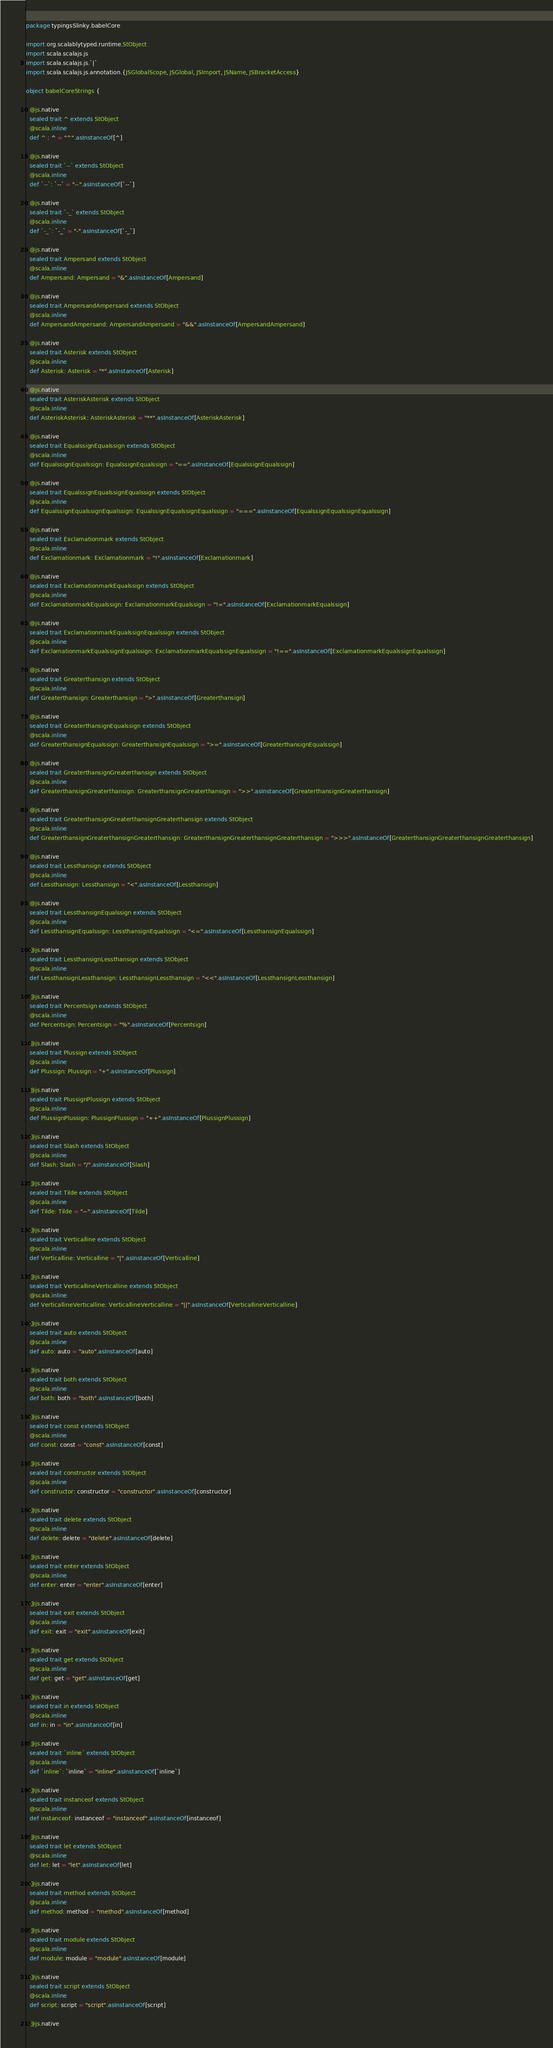<code> <loc_0><loc_0><loc_500><loc_500><_Scala_>package typingsSlinky.babelCore

import org.scalablytyped.runtime.StObject
import scala.scalajs.js
import scala.scalajs.js.`|`
import scala.scalajs.js.annotation.{JSGlobalScope, JSGlobal, JSImport, JSName, JSBracketAccess}

object babelCoreStrings {
  
  @js.native
  sealed trait ^ extends StObject
  @scala.inline
  def ^ : ^ = "^".asInstanceOf[^]
  
  @js.native
  sealed trait `--` extends StObject
  @scala.inline
  def `--`: `--` = "--".asInstanceOf[`--`]
  
  @js.native
  sealed trait `-_` extends StObject
  @scala.inline
  def `-_`: `-_` = "-".asInstanceOf[`-_`]
  
  @js.native
  sealed trait Ampersand extends StObject
  @scala.inline
  def Ampersand: Ampersand = "&".asInstanceOf[Ampersand]
  
  @js.native
  sealed trait AmpersandAmpersand extends StObject
  @scala.inline
  def AmpersandAmpersand: AmpersandAmpersand = "&&".asInstanceOf[AmpersandAmpersand]
  
  @js.native
  sealed trait Asterisk extends StObject
  @scala.inline
  def Asterisk: Asterisk = "*".asInstanceOf[Asterisk]
  
  @js.native
  sealed trait AsteriskAsterisk extends StObject
  @scala.inline
  def AsteriskAsterisk: AsteriskAsterisk = "**".asInstanceOf[AsteriskAsterisk]
  
  @js.native
  sealed trait EqualssignEqualssign extends StObject
  @scala.inline
  def EqualssignEqualssign: EqualssignEqualssign = "==".asInstanceOf[EqualssignEqualssign]
  
  @js.native
  sealed trait EqualssignEqualssignEqualssign extends StObject
  @scala.inline
  def EqualssignEqualssignEqualssign: EqualssignEqualssignEqualssign = "===".asInstanceOf[EqualssignEqualssignEqualssign]
  
  @js.native
  sealed trait Exclamationmark extends StObject
  @scala.inline
  def Exclamationmark: Exclamationmark = "!".asInstanceOf[Exclamationmark]
  
  @js.native
  sealed trait ExclamationmarkEqualssign extends StObject
  @scala.inline
  def ExclamationmarkEqualssign: ExclamationmarkEqualssign = "!=".asInstanceOf[ExclamationmarkEqualssign]
  
  @js.native
  sealed trait ExclamationmarkEqualssignEqualssign extends StObject
  @scala.inline
  def ExclamationmarkEqualssignEqualssign: ExclamationmarkEqualssignEqualssign = "!==".asInstanceOf[ExclamationmarkEqualssignEqualssign]
  
  @js.native
  sealed trait Greaterthansign extends StObject
  @scala.inline
  def Greaterthansign: Greaterthansign = ">".asInstanceOf[Greaterthansign]
  
  @js.native
  sealed trait GreaterthansignEqualssign extends StObject
  @scala.inline
  def GreaterthansignEqualssign: GreaterthansignEqualssign = ">=".asInstanceOf[GreaterthansignEqualssign]
  
  @js.native
  sealed trait GreaterthansignGreaterthansign extends StObject
  @scala.inline
  def GreaterthansignGreaterthansign: GreaterthansignGreaterthansign = ">>".asInstanceOf[GreaterthansignGreaterthansign]
  
  @js.native
  sealed trait GreaterthansignGreaterthansignGreaterthansign extends StObject
  @scala.inline
  def GreaterthansignGreaterthansignGreaterthansign: GreaterthansignGreaterthansignGreaterthansign = ">>>".asInstanceOf[GreaterthansignGreaterthansignGreaterthansign]
  
  @js.native
  sealed trait Lessthansign extends StObject
  @scala.inline
  def Lessthansign: Lessthansign = "<".asInstanceOf[Lessthansign]
  
  @js.native
  sealed trait LessthansignEqualssign extends StObject
  @scala.inline
  def LessthansignEqualssign: LessthansignEqualssign = "<=".asInstanceOf[LessthansignEqualssign]
  
  @js.native
  sealed trait LessthansignLessthansign extends StObject
  @scala.inline
  def LessthansignLessthansign: LessthansignLessthansign = "<<".asInstanceOf[LessthansignLessthansign]
  
  @js.native
  sealed trait Percentsign extends StObject
  @scala.inline
  def Percentsign: Percentsign = "%".asInstanceOf[Percentsign]
  
  @js.native
  sealed trait Plussign extends StObject
  @scala.inline
  def Plussign: Plussign = "+".asInstanceOf[Plussign]
  
  @js.native
  sealed trait PlussignPlussign extends StObject
  @scala.inline
  def PlussignPlussign: PlussignPlussign = "++".asInstanceOf[PlussignPlussign]
  
  @js.native
  sealed trait Slash extends StObject
  @scala.inline
  def Slash: Slash = "/".asInstanceOf[Slash]
  
  @js.native
  sealed trait Tilde extends StObject
  @scala.inline
  def Tilde: Tilde = "~".asInstanceOf[Tilde]
  
  @js.native
  sealed trait Verticalline extends StObject
  @scala.inline
  def Verticalline: Verticalline = "|".asInstanceOf[Verticalline]
  
  @js.native
  sealed trait VerticallineVerticalline extends StObject
  @scala.inline
  def VerticallineVerticalline: VerticallineVerticalline = "||".asInstanceOf[VerticallineVerticalline]
  
  @js.native
  sealed trait auto extends StObject
  @scala.inline
  def auto: auto = "auto".asInstanceOf[auto]
  
  @js.native
  sealed trait both extends StObject
  @scala.inline
  def both: both = "both".asInstanceOf[both]
  
  @js.native
  sealed trait const extends StObject
  @scala.inline
  def const: const = "const".asInstanceOf[const]
  
  @js.native
  sealed trait constructor extends StObject
  @scala.inline
  def constructor: constructor = "constructor".asInstanceOf[constructor]
  
  @js.native
  sealed trait delete extends StObject
  @scala.inline
  def delete: delete = "delete".asInstanceOf[delete]
  
  @js.native
  sealed trait enter extends StObject
  @scala.inline
  def enter: enter = "enter".asInstanceOf[enter]
  
  @js.native
  sealed trait exit extends StObject
  @scala.inline
  def exit: exit = "exit".asInstanceOf[exit]
  
  @js.native
  sealed trait get extends StObject
  @scala.inline
  def get: get = "get".asInstanceOf[get]
  
  @js.native
  sealed trait in extends StObject
  @scala.inline
  def in: in = "in".asInstanceOf[in]
  
  @js.native
  sealed trait `inline` extends StObject
  @scala.inline
  def `inline`: `inline` = "inline".asInstanceOf[`inline`]
  
  @js.native
  sealed trait instanceof extends StObject
  @scala.inline
  def instanceof: instanceof = "instanceof".asInstanceOf[instanceof]
  
  @js.native
  sealed trait let extends StObject
  @scala.inline
  def let: let = "let".asInstanceOf[let]
  
  @js.native
  sealed trait method extends StObject
  @scala.inline
  def method: method = "method".asInstanceOf[method]
  
  @js.native
  sealed trait module extends StObject
  @scala.inline
  def module: module = "module".asInstanceOf[module]
  
  @js.native
  sealed trait script extends StObject
  @scala.inline
  def script: script = "script".asInstanceOf[script]
  
  @js.native</code> 